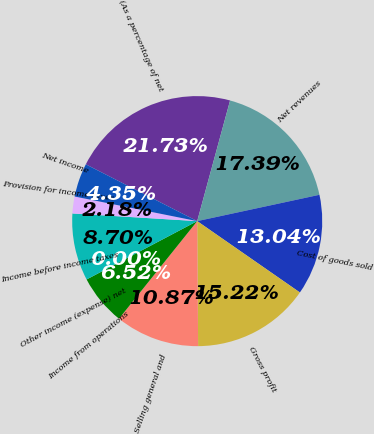Convert chart. <chart><loc_0><loc_0><loc_500><loc_500><pie_chart><fcel>(As a percentage of net<fcel>Net revenues<fcel>Cost of goods sold<fcel>Gross profit<fcel>Selling general and<fcel>Income from operations<fcel>Other income (expense) net<fcel>Income before income taxes<fcel>Provision for income taxes<fcel>Net income<nl><fcel>21.73%<fcel>17.39%<fcel>13.04%<fcel>15.22%<fcel>10.87%<fcel>6.52%<fcel>0.0%<fcel>8.7%<fcel>2.18%<fcel>4.35%<nl></chart> 